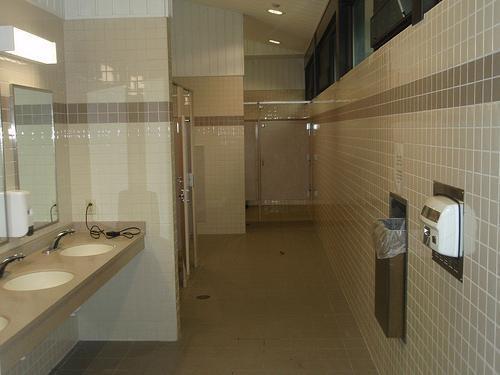How many sinks are there?
Give a very brief answer. 2. 